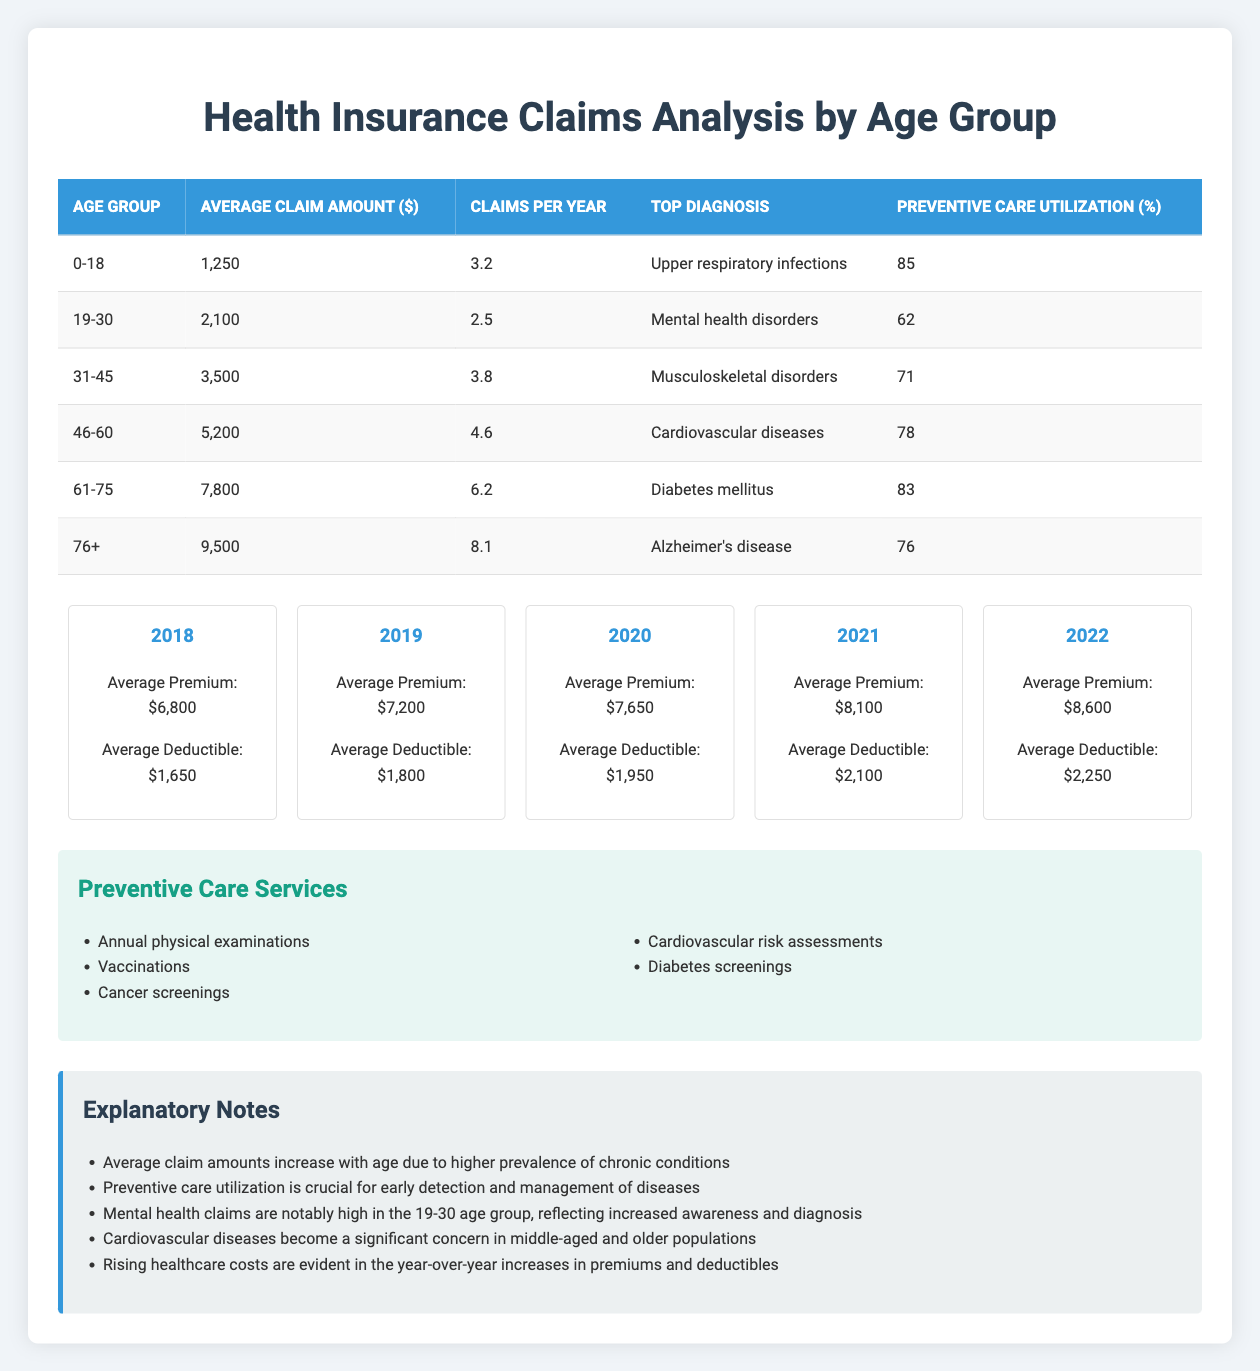What is the average claim amount for the age group 31-45? Looking at the table, the average claim amount listed for the age group 31-45 is $3,500.
Answer: $3,500 Which age group has the highest number of claims per year? The table indicates that the age group 76+ has the highest claims per year at 8.1 claims.
Answer: 76+ What percentage of preventive care utilization is reported for ages 19-30? The preventive care utilization for the age group 19-30, as shown in the table, is 62%.
Answer: 62% Is the top diagnosis for the age group 0-18 related to respiratory issues? The table shows that the top diagnosis for the age group 0-18 is upper respiratory infections, which confirms the statement is true.
Answer: Yes Calculate the average claim amount across all age groups. To find the average claim amount across all age groups, we first sum the average claim amounts: 1250 + 2100 + 3500 + 5200 + 7800 + 9500 = 29950. Then divide by the number of age groups, which is 6: 29950 / 6 = 4991.67.
Answer: 4991.67 For which age group is the top diagnosis a mental health disorder? According to the table, the top diagnosis listed for the age group 19-30 is mental health disorders.
Answer: 19-30 Are average premiums increasing every year based on the trend data? When scanning through the cost trends in the table, it is apparent that each year the average premium increases from $6,800 in 2018 to $8,600 in 2022, which confirms the statement is true.
Answer: Yes What is the difference in average claim amounts between the age groups 61-75 and 76+? From the table, the average claim amount for the age group 61-75 is $7,800 and for 76+ it is $9,500. The difference is calculated as $9,500 - $7,800 = $1,700.
Answer: $1,700 What trend is observed in deductible amounts over the years? Reviewing the cost trends, we see that the average deductible has increased yearly, starting from $1,650 in 2018 to $2,250 in 2022, indicating a rising trend.
Answer: Rising trend 